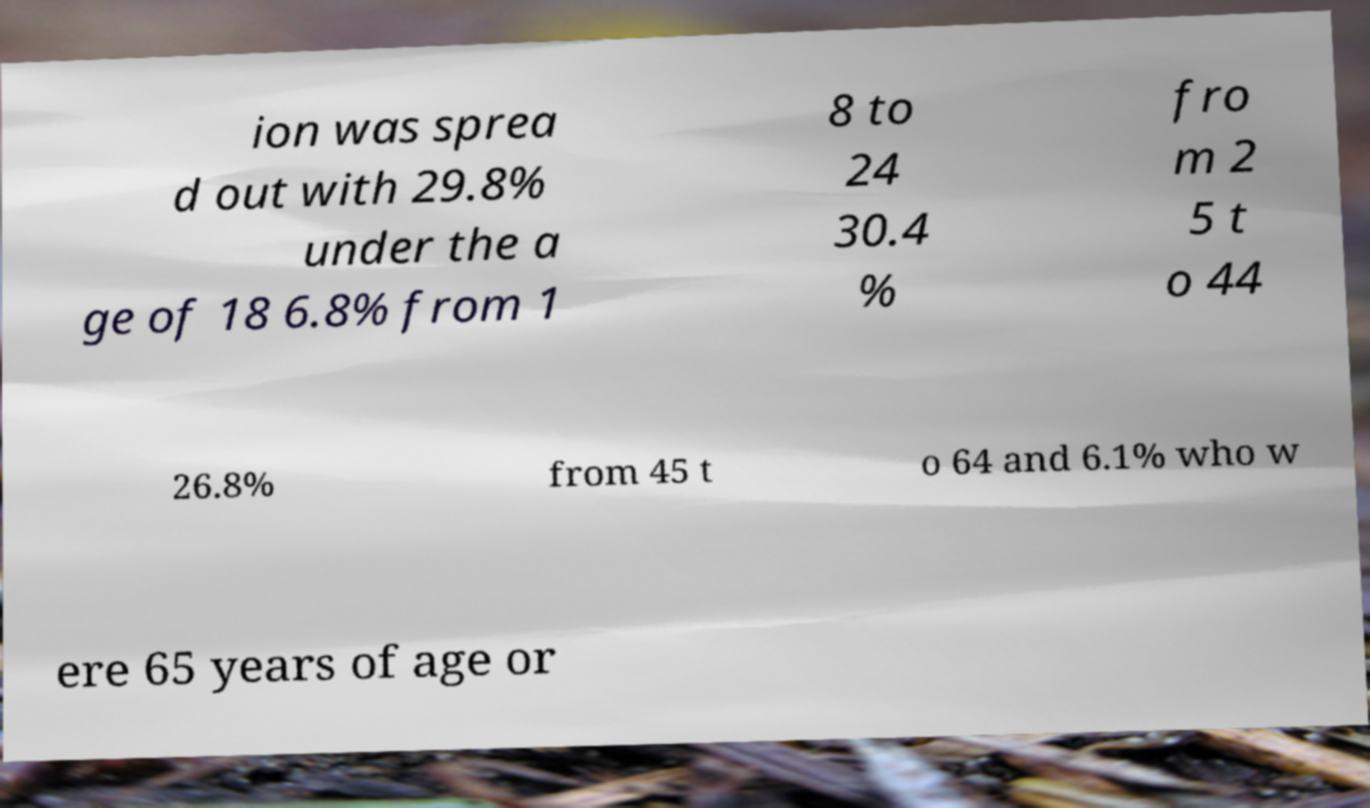Could you assist in decoding the text presented in this image and type it out clearly? ion was sprea d out with 29.8% under the a ge of 18 6.8% from 1 8 to 24 30.4 % fro m 2 5 t o 44 26.8% from 45 t o 64 and 6.1% who w ere 65 years of age or 